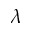Convert formula to latex. <formula><loc_0><loc_0><loc_500><loc_500>\lambda</formula> 